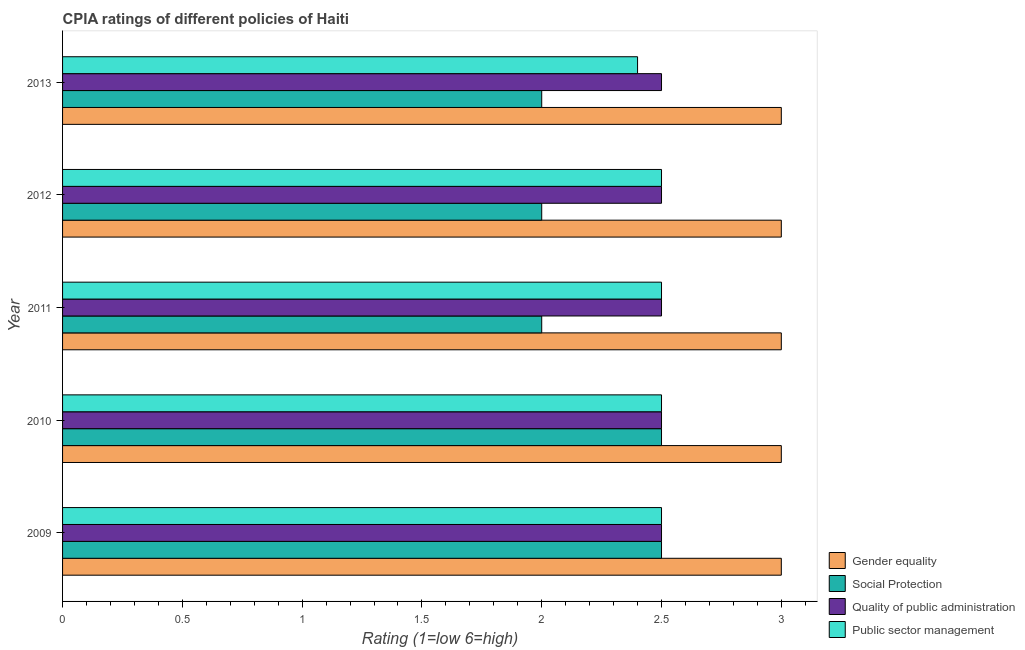Are the number of bars on each tick of the Y-axis equal?
Make the answer very short. Yes. How many bars are there on the 1st tick from the top?
Ensure brevity in your answer.  4. What is the label of the 5th group of bars from the top?
Ensure brevity in your answer.  2009. Across all years, what is the maximum cpia rating of gender equality?
Offer a very short reply. 3. Across all years, what is the minimum cpia rating of social protection?
Your answer should be very brief. 2. In which year was the cpia rating of public sector management minimum?
Keep it short and to the point. 2013. What is the difference between the cpia rating of gender equality in 2009 and the cpia rating of public sector management in 2013?
Your response must be concise. 0.6. What is the average cpia rating of public sector management per year?
Give a very brief answer. 2.48. In how many years, is the cpia rating of gender equality greater than 1.5 ?
Ensure brevity in your answer.  5. What is the ratio of the cpia rating of gender equality in 2010 to that in 2011?
Provide a short and direct response. 1. Is the cpia rating of social protection in 2010 less than that in 2011?
Give a very brief answer. No. In how many years, is the cpia rating of social protection greater than the average cpia rating of social protection taken over all years?
Make the answer very short. 2. Is the sum of the cpia rating of quality of public administration in 2009 and 2011 greater than the maximum cpia rating of social protection across all years?
Ensure brevity in your answer.  Yes. Is it the case that in every year, the sum of the cpia rating of quality of public administration and cpia rating of gender equality is greater than the sum of cpia rating of public sector management and cpia rating of social protection?
Offer a terse response. Yes. What does the 3rd bar from the top in 2012 represents?
Your answer should be compact. Social Protection. What does the 4th bar from the bottom in 2012 represents?
Provide a short and direct response. Public sector management. Is it the case that in every year, the sum of the cpia rating of gender equality and cpia rating of social protection is greater than the cpia rating of quality of public administration?
Provide a succinct answer. Yes. What is the difference between two consecutive major ticks on the X-axis?
Your answer should be compact. 0.5. Are the values on the major ticks of X-axis written in scientific E-notation?
Ensure brevity in your answer.  No. Does the graph contain any zero values?
Provide a short and direct response. No. Where does the legend appear in the graph?
Give a very brief answer. Bottom right. How are the legend labels stacked?
Provide a short and direct response. Vertical. What is the title of the graph?
Offer a terse response. CPIA ratings of different policies of Haiti. What is the label or title of the X-axis?
Provide a succinct answer. Rating (1=low 6=high). What is the label or title of the Y-axis?
Provide a short and direct response. Year. What is the Rating (1=low 6=high) in Gender equality in 2009?
Make the answer very short. 3. What is the Rating (1=low 6=high) of Public sector management in 2009?
Your response must be concise. 2.5. What is the Rating (1=low 6=high) in Gender equality in 2011?
Offer a very short reply. 3. What is the Rating (1=low 6=high) in Social Protection in 2011?
Your answer should be compact. 2. What is the Rating (1=low 6=high) of Quality of public administration in 2011?
Your answer should be very brief. 2.5. What is the Rating (1=low 6=high) of Gender equality in 2012?
Your answer should be compact. 3. What is the Rating (1=low 6=high) in Quality of public administration in 2012?
Your answer should be compact. 2.5. What is the Rating (1=low 6=high) of Public sector management in 2012?
Keep it short and to the point. 2.5. What is the Rating (1=low 6=high) in Quality of public administration in 2013?
Offer a very short reply. 2.5. What is the Rating (1=low 6=high) in Public sector management in 2013?
Give a very brief answer. 2.4. Across all years, what is the minimum Rating (1=low 6=high) in Gender equality?
Provide a short and direct response. 3. Across all years, what is the minimum Rating (1=low 6=high) of Social Protection?
Your answer should be compact. 2. Across all years, what is the minimum Rating (1=low 6=high) of Public sector management?
Offer a very short reply. 2.4. What is the total Rating (1=low 6=high) in Social Protection in the graph?
Offer a terse response. 11. What is the total Rating (1=low 6=high) of Quality of public administration in the graph?
Ensure brevity in your answer.  12.5. What is the total Rating (1=low 6=high) of Public sector management in the graph?
Make the answer very short. 12.4. What is the difference between the Rating (1=low 6=high) in Gender equality in 2009 and that in 2010?
Offer a terse response. 0. What is the difference between the Rating (1=low 6=high) of Public sector management in 2009 and that in 2010?
Offer a terse response. 0. What is the difference between the Rating (1=low 6=high) of Gender equality in 2009 and that in 2013?
Offer a terse response. 0. What is the difference between the Rating (1=low 6=high) in Quality of public administration in 2009 and that in 2013?
Offer a terse response. 0. What is the difference between the Rating (1=low 6=high) in Public sector management in 2009 and that in 2013?
Your answer should be compact. 0.1. What is the difference between the Rating (1=low 6=high) in Quality of public administration in 2010 and that in 2012?
Your answer should be compact. 0. What is the difference between the Rating (1=low 6=high) of Public sector management in 2010 and that in 2012?
Give a very brief answer. 0. What is the difference between the Rating (1=low 6=high) of Gender equality in 2010 and that in 2013?
Your answer should be compact. 0. What is the difference between the Rating (1=low 6=high) in Quality of public administration in 2010 and that in 2013?
Keep it short and to the point. 0. What is the difference between the Rating (1=low 6=high) of Public sector management in 2010 and that in 2013?
Make the answer very short. 0.1. What is the difference between the Rating (1=low 6=high) in Social Protection in 2011 and that in 2012?
Keep it short and to the point. 0. What is the difference between the Rating (1=low 6=high) in Quality of public administration in 2011 and that in 2012?
Provide a succinct answer. 0. What is the difference between the Rating (1=low 6=high) in Public sector management in 2011 and that in 2012?
Provide a succinct answer. 0. What is the difference between the Rating (1=low 6=high) of Social Protection in 2011 and that in 2013?
Make the answer very short. 0. What is the difference between the Rating (1=low 6=high) of Quality of public administration in 2011 and that in 2013?
Your answer should be very brief. 0. What is the difference between the Rating (1=low 6=high) of Public sector management in 2011 and that in 2013?
Your answer should be compact. 0.1. What is the difference between the Rating (1=low 6=high) of Gender equality in 2012 and that in 2013?
Your answer should be very brief. 0. What is the difference between the Rating (1=low 6=high) of Quality of public administration in 2012 and that in 2013?
Your answer should be very brief. 0. What is the difference between the Rating (1=low 6=high) in Gender equality in 2009 and the Rating (1=low 6=high) in Social Protection in 2010?
Keep it short and to the point. 0.5. What is the difference between the Rating (1=low 6=high) of Social Protection in 2009 and the Rating (1=low 6=high) of Public sector management in 2010?
Ensure brevity in your answer.  0. What is the difference between the Rating (1=low 6=high) of Quality of public administration in 2009 and the Rating (1=low 6=high) of Public sector management in 2010?
Offer a terse response. 0. What is the difference between the Rating (1=low 6=high) of Gender equality in 2009 and the Rating (1=low 6=high) of Public sector management in 2011?
Your answer should be very brief. 0.5. What is the difference between the Rating (1=low 6=high) of Social Protection in 2009 and the Rating (1=low 6=high) of Quality of public administration in 2011?
Provide a succinct answer. 0. What is the difference between the Rating (1=low 6=high) of Social Protection in 2009 and the Rating (1=low 6=high) of Public sector management in 2012?
Give a very brief answer. 0. What is the difference between the Rating (1=low 6=high) of Quality of public administration in 2009 and the Rating (1=low 6=high) of Public sector management in 2012?
Offer a terse response. 0. What is the difference between the Rating (1=low 6=high) of Gender equality in 2009 and the Rating (1=low 6=high) of Quality of public administration in 2013?
Ensure brevity in your answer.  0.5. What is the difference between the Rating (1=low 6=high) of Social Protection in 2009 and the Rating (1=low 6=high) of Quality of public administration in 2013?
Provide a succinct answer. 0. What is the difference between the Rating (1=low 6=high) in Gender equality in 2010 and the Rating (1=low 6=high) in Quality of public administration in 2011?
Offer a very short reply. 0.5. What is the difference between the Rating (1=low 6=high) in Social Protection in 2010 and the Rating (1=low 6=high) in Public sector management in 2011?
Ensure brevity in your answer.  0. What is the difference between the Rating (1=low 6=high) of Quality of public administration in 2010 and the Rating (1=low 6=high) of Public sector management in 2011?
Keep it short and to the point. 0. What is the difference between the Rating (1=low 6=high) of Gender equality in 2010 and the Rating (1=low 6=high) of Quality of public administration in 2012?
Offer a terse response. 0.5. What is the difference between the Rating (1=low 6=high) of Gender equality in 2010 and the Rating (1=low 6=high) of Public sector management in 2012?
Offer a very short reply. 0.5. What is the difference between the Rating (1=low 6=high) in Social Protection in 2010 and the Rating (1=low 6=high) in Quality of public administration in 2012?
Offer a terse response. 0. What is the difference between the Rating (1=low 6=high) of Quality of public administration in 2010 and the Rating (1=low 6=high) of Public sector management in 2012?
Provide a succinct answer. 0. What is the difference between the Rating (1=low 6=high) of Social Protection in 2010 and the Rating (1=low 6=high) of Quality of public administration in 2013?
Your answer should be compact. 0. What is the difference between the Rating (1=low 6=high) in Social Protection in 2010 and the Rating (1=low 6=high) in Public sector management in 2013?
Your answer should be compact. 0.1. What is the difference between the Rating (1=low 6=high) of Quality of public administration in 2010 and the Rating (1=low 6=high) of Public sector management in 2013?
Offer a very short reply. 0.1. What is the difference between the Rating (1=low 6=high) of Gender equality in 2011 and the Rating (1=low 6=high) of Quality of public administration in 2012?
Provide a succinct answer. 0.5. What is the difference between the Rating (1=low 6=high) in Social Protection in 2011 and the Rating (1=low 6=high) in Quality of public administration in 2012?
Make the answer very short. -0.5. What is the difference between the Rating (1=low 6=high) of Gender equality in 2011 and the Rating (1=low 6=high) of Public sector management in 2013?
Make the answer very short. 0.6. What is the difference between the Rating (1=low 6=high) of Quality of public administration in 2011 and the Rating (1=low 6=high) of Public sector management in 2013?
Provide a short and direct response. 0.1. What is the difference between the Rating (1=low 6=high) of Gender equality in 2012 and the Rating (1=low 6=high) of Social Protection in 2013?
Offer a very short reply. 1. What is the difference between the Rating (1=low 6=high) of Gender equality in 2012 and the Rating (1=low 6=high) of Quality of public administration in 2013?
Provide a succinct answer. 0.5. What is the difference between the Rating (1=low 6=high) in Gender equality in 2012 and the Rating (1=low 6=high) in Public sector management in 2013?
Keep it short and to the point. 0.6. What is the difference between the Rating (1=low 6=high) in Social Protection in 2012 and the Rating (1=low 6=high) in Quality of public administration in 2013?
Provide a short and direct response. -0.5. What is the difference between the Rating (1=low 6=high) in Social Protection in 2012 and the Rating (1=low 6=high) in Public sector management in 2013?
Make the answer very short. -0.4. What is the difference between the Rating (1=low 6=high) of Quality of public administration in 2012 and the Rating (1=low 6=high) of Public sector management in 2013?
Keep it short and to the point. 0.1. What is the average Rating (1=low 6=high) in Public sector management per year?
Keep it short and to the point. 2.48. In the year 2009, what is the difference between the Rating (1=low 6=high) of Gender equality and Rating (1=low 6=high) of Social Protection?
Ensure brevity in your answer.  0.5. In the year 2009, what is the difference between the Rating (1=low 6=high) in Social Protection and Rating (1=low 6=high) in Quality of public administration?
Your answer should be compact. 0. In the year 2009, what is the difference between the Rating (1=low 6=high) of Quality of public administration and Rating (1=low 6=high) of Public sector management?
Your answer should be very brief. 0. In the year 2010, what is the difference between the Rating (1=low 6=high) of Gender equality and Rating (1=low 6=high) of Public sector management?
Offer a very short reply. 0.5. In the year 2010, what is the difference between the Rating (1=low 6=high) in Social Protection and Rating (1=low 6=high) in Quality of public administration?
Provide a succinct answer. 0. In the year 2010, what is the difference between the Rating (1=low 6=high) in Quality of public administration and Rating (1=low 6=high) in Public sector management?
Offer a terse response. 0. In the year 2011, what is the difference between the Rating (1=low 6=high) in Gender equality and Rating (1=low 6=high) in Social Protection?
Provide a succinct answer. 1. In the year 2011, what is the difference between the Rating (1=low 6=high) in Gender equality and Rating (1=low 6=high) in Quality of public administration?
Offer a very short reply. 0.5. In the year 2011, what is the difference between the Rating (1=low 6=high) of Gender equality and Rating (1=low 6=high) of Public sector management?
Your response must be concise. 0.5. In the year 2011, what is the difference between the Rating (1=low 6=high) of Social Protection and Rating (1=low 6=high) of Public sector management?
Ensure brevity in your answer.  -0.5. In the year 2011, what is the difference between the Rating (1=low 6=high) in Quality of public administration and Rating (1=low 6=high) in Public sector management?
Offer a terse response. 0. In the year 2012, what is the difference between the Rating (1=low 6=high) of Gender equality and Rating (1=low 6=high) of Quality of public administration?
Offer a very short reply. 0.5. In the year 2012, what is the difference between the Rating (1=low 6=high) in Gender equality and Rating (1=low 6=high) in Public sector management?
Provide a short and direct response. 0.5. In the year 2012, what is the difference between the Rating (1=low 6=high) of Social Protection and Rating (1=low 6=high) of Quality of public administration?
Provide a short and direct response. -0.5. In the year 2012, what is the difference between the Rating (1=low 6=high) in Social Protection and Rating (1=low 6=high) in Public sector management?
Offer a terse response. -0.5. In the year 2013, what is the difference between the Rating (1=low 6=high) of Gender equality and Rating (1=low 6=high) of Social Protection?
Your answer should be compact. 1. In the year 2013, what is the difference between the Rating (1=low 6=high) in Gender equality and Rating (1=low 6=high) in Public sector management?
Provide a short and direct response. 0.6. In the year 2013, what is the difference between the Rating (1=low 6=high) of Social Protection and Rating (1=low 6=high) of Quality of public administration?
Your answer should be compact. -0.5. In the year 2013, what is the difference between the Rating (1=low 6=high) in Social Protection and Rating (1=low 6=high) in Public sector management?
Offer a very short reply. -0.4. What is the ratio of the Rating (1=low 6=high) of Gender equality in 2009 to that in 2010?
Provide a short and direct response. 1. What is the ratio of the Rating (1=low 6=high) in Quality of public administration in 2009 to that in 2010?
Ensure brevity in your answer.  1. What is the ratio of the Rating (1=low 6=high) in Social Protection in 2009 to that in 2011?
Your answer should be very brief. 1.25. What is the ratio of the Rating (1=low 6=high) in Quality of public administration in 2009 to that in 2011?
Make the answer very short. 1. What is the ratio of the Rating (1=low 6=high) in Gender equality in 2009 to that in 2012?
Ensure brevity in your answer.  1. What is the ratio of the Rating (1=low 6=high) of Social Protection in 2009 to that in 2012?
Make the answer very short. 1.25. What is the ratio of the Rating (1=low 6=high) in Gender equality in 2009 to that in 2013?
Your answer should be compact. 1. What is the ratio of the Rating (1=low 6=high) of Public sector management in 2009 to that in 2013?
Your answer should be compact. 1.04. What is the ratio of the Rating (1=low 6=high) of Social Protection in 2010 to that in 2011?
Provide a succinct answer. 1.25. What is the ratio of the Rating (1=low 6=high) of Quality of public administration in 2010 to that in 2011?
Provide a short and direct response. 1. What is the ratio of the Rating (1=low 6=high) of Quality of public administration in 2010 to that in 2012?
Your answer should be compact. 1. What is the ratio of the Rating (1=low 6=high) of Gender equality in 2010 to that in 2013?
Your response must be concise. 1. What is the ratio of the Rating (1=low 6=high) of Social Protection in 2010 to that in 2013?
Your response must be concise. 1.25. What is the ratio of the Rating (1=low 6=high) of Quality of public administration in 2010 to that in 2013?
Provide a short and direct response. 1. What is the ratio of the Rating (1=low 6=high) in Public sector management in 2010 to that in 2013?
Keep it short and to the point. 1.04. What is the ratio of the Rating (1=low 6=high) of Social Protection in 2011 to that in 2012?
Your answer should be compact. 1. What is the ratio of the Rating (1=low 6=high) of Quality of public administration in 2011 to that in 2012?
Offer a terse response. 1. What is the ratio of the Rating (1=low 6=high) of Public sector management in 2011 to that in 2012?
Your answer should be very brief. 1. What is the ratio of the Rating (1=low 6=high) in Quality of public administration in 2011 to that in 2013?
Provide a succinct answer. 1. What is the ratio of the Rating (1=low 6=high) of Public sector management in 2011 to that in 2013?
Your answer should be compact. 1.04. What is the ratio of the Rating (1=low 6=high) in Quality of public administration in 2012 to that in 2013?
Make the answer very short. 1. What is the ratio of the Rating (1=low 6=high) in Public sector management in 2012 to that in 2013?
Keep it short and to the point. 1.04. What is the difference between the highest and the second highest Rating (1=low 6=high) of Gender equality?
Provide a short and direct response. 0. What is the difference between the highest and the lowest Rating (1=low 6=high) of Gender equality?
Offer a very short reply. 0. What is the difference between the highest and the lowest Rating (1=low 6=high) of Social Protection?
Ensure brevity in your answer.  0.5. What is the difference between the highest and the lowest Rating (1=low 6=high) in Public sector management?
Your response must be concise. 0.1. 